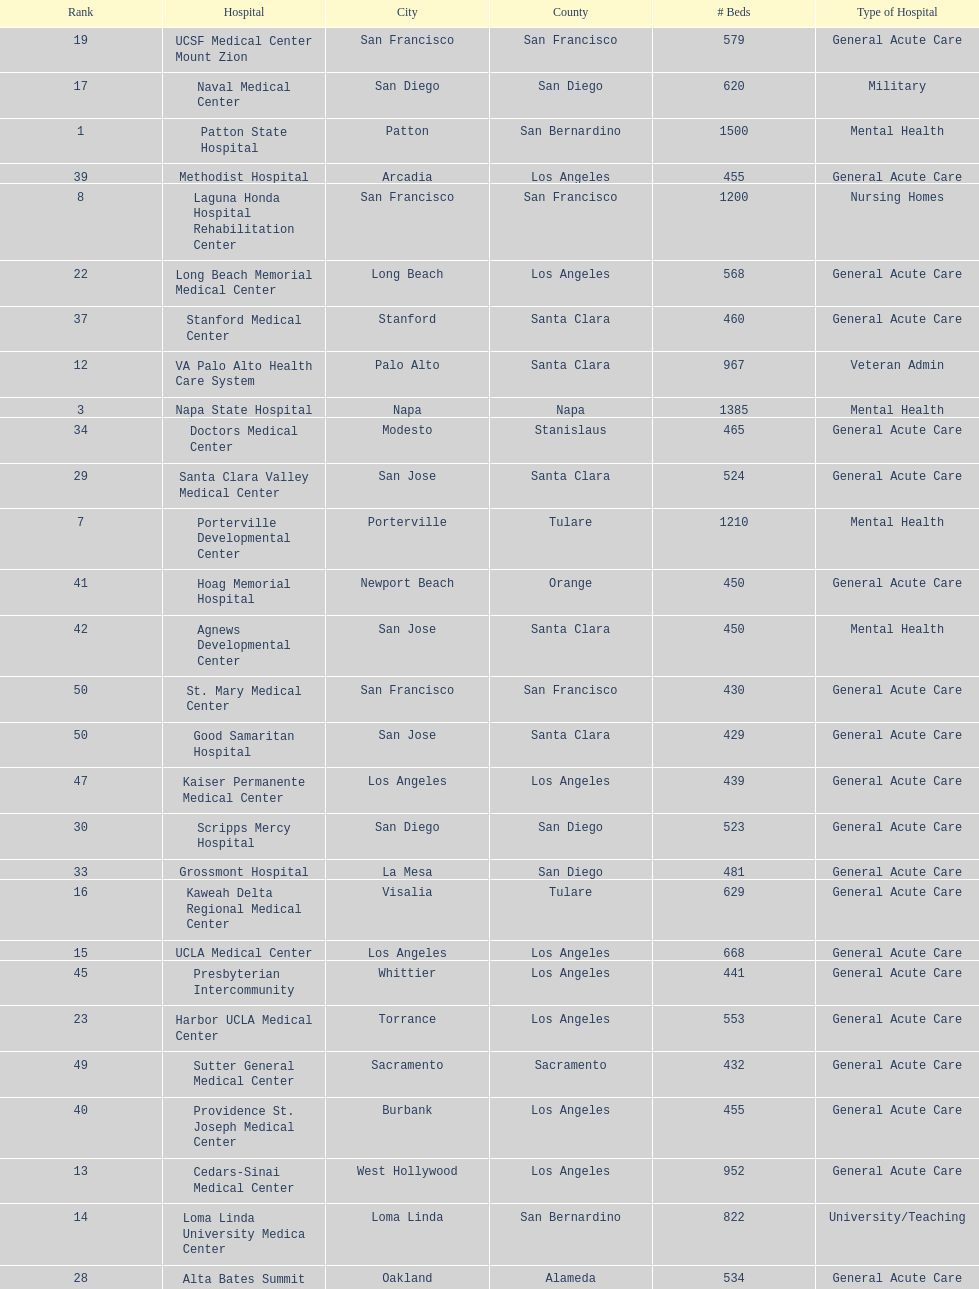How many more general acute care hospitals are there in california than rehabilitation hospitals? 33. 